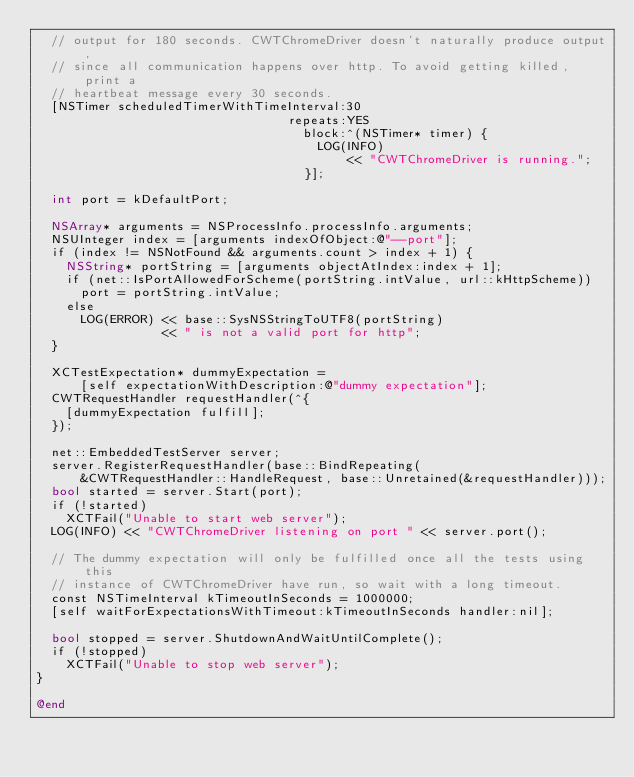Convert code to text. <code><loc_0><loc_0><loc_500><loc_500><_ObjectiveC_>  // output for 180 seconds. CWTChromeDriver doesn't naturally produce output,
  // since all communication happens over http. To avoid getting killed, print a
  // heartbeat message every 30 seconds.
  [NSTimer scheduledTimerWithTimeInterval:30
                                  repeats:YES
                                    block:^(NSTimer* timer) {
                                      LOG(INFO)
                                          << "CWTChromeDriver is running.";
                                    }];

  int port = kDefaultPort;

  NSArray* arguments = NSProcessInfo.processInfo.arguments;
  NSUInteger index = [arguments indexOfObject:@"--port"];
  if (index != NSNotFound && arguments.count > index + 1) {
    NSString* portString = [arguments objectAtIndex:index + 1];
    if (net::IsPortAllowedForScheme(portString.intValue, url::kHttpScheme))
      port = portString.intValue;
    else
      LOG(ERROR) << base::SysNSStringToUTF8(portString)
                 << " is not a valid port for http";
  }

  XCTestExpectation* dummyExpectation =
      [self expectationWithDescription:@"dummy expectation"];
  CWTRequestHandler requestHandler(^{
    [dummyExpectation fulfill];
  });

  net::EmbeddedTestServer server;
  server.RegisterRequestHandler(base::BindRepeating(
      &CWTRequestHandler::HandleRequest, base::Unretained(&requestHandler)));
  bool started = server.Start(port);
  if (!started)
    XCTFail("Unable to start web server");
  LOG(INFO) << "CWTChromeDriver listening on port " << server.port();

  // The dummy expectation will only be fulfilled once all the tests using this
  // instance of CWTChromeDriver have run, so wait with a long timeout.
  const NSTimeInterval kTimeoutInSeconds = 1000000;
  [self waitForExpectationsWithTimeout:kTimeoutInSeconds handler:nil];

  bool stopped = server.ShutdownAndWaitUntilComplete();
  if (!stopped)
    XCTFail("Unable to stop web server");
}

@end
</code> 